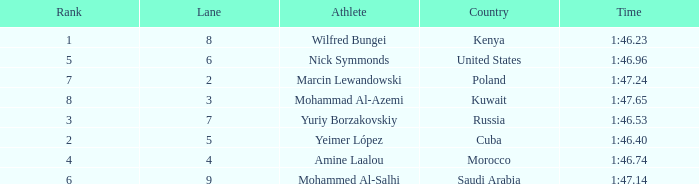What is the Rank of the Athlete with a Time of 1:47.65 and in Lane 3 or larger? None. 